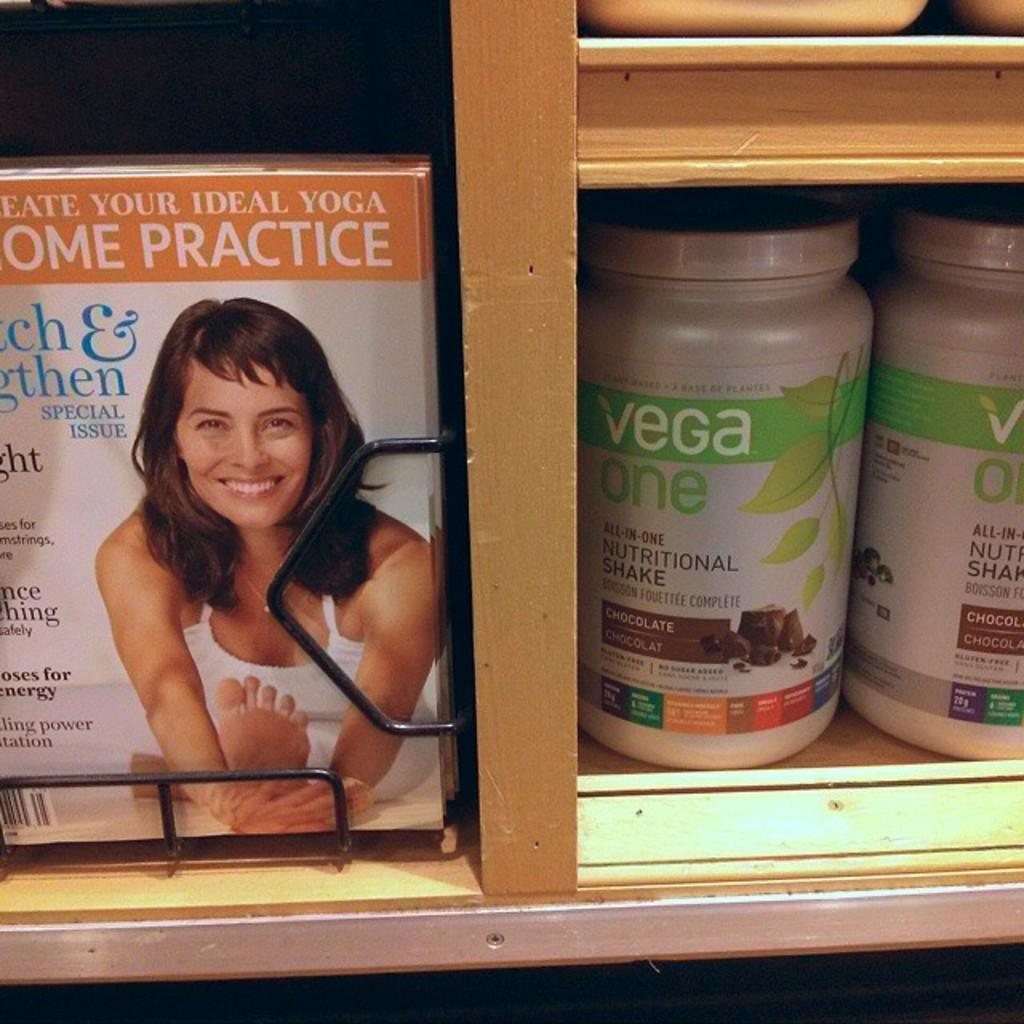What is the main object in the image? There is a book in the image. What can be found on the book? The book has text and an image of a woman. What else is visible in the image? There are bottles arranged in a rack in the image. How does the paper feel in the image? There is no paper mentioned in the image; the book has text and an image of a woman. 